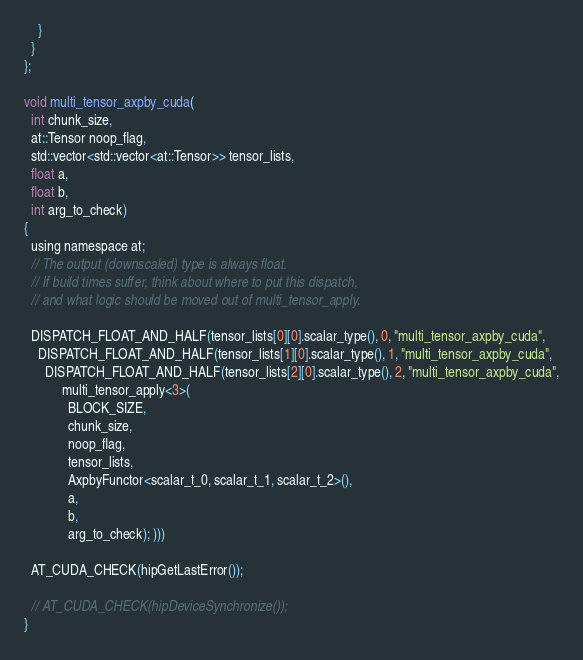Convert code to text. <code><loc_0><loc_0><loc_500><loc_500><_Cuda_>    }
  }
};

void multi_tensor_axpby_cuda(
  int chunk_size,
  at::Tensor noop_flag,
  std::vector<std::vector<at::Tensor>> tensor_lists,
  float a,
  float b,
  int arg_to_check)
{
  using namespace at;
  // The output (downscaled) type is always float.
  // If build times suffer, think about where to put this dispatch,
  // and what logic should be moved out of multi_tensor_apply.

  DISPATCH_FLOAT_AND_HALF(tensor_lists[0][0].scalar_type(), 0, "multi_tensor_axpby_cuda",
    DISPATCH_FLOAT_AND_HALF(tensor_lists[1][0].scalar_type(), 1, "multi_tensor_axpby_cuda",
      DISPATCH_FLOAT_AND_HALF(tensor_lists[2][0].scalar_type(), 2, "multi_tensor_axpby_cuda",
           multi_tensor_apply<3>(
             BLOCK_SIZE,
             chunk_size,
             noop_flag,
             tensor_lists,
             AxpbyFunctor<scalar_t_0, scalar_t_1, scalar_t_2>(),
             a,
             b,
             arg_to_check); )))

  AT_CUDA_CHECK(hipGetLastError());

  // AT_CUDA_CHECK(hipDeviceSynchronize());
}
</code> 